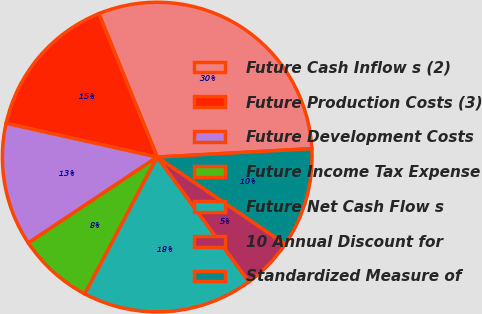Convert chart to OTSL. <chart><loc_0><loc_0><loc_500><loc_500><pie_chart><fcel>Future Cash Inflow s (2)<fcel>Future Production Costs (3)<fcel>Future Development Costs<fcel>Future Income Tax Expense<fcel>Future Net Cash Flow s<fcel>10 Annual Discount for<fcel>Standardized Measure of<nl><fcel>30.28%<fcel>15.35%<fcel>12.86%<fcel>7.89%<fcel>17.84%<fcel>5.4%<fcel>10.37%<nl></chart> 